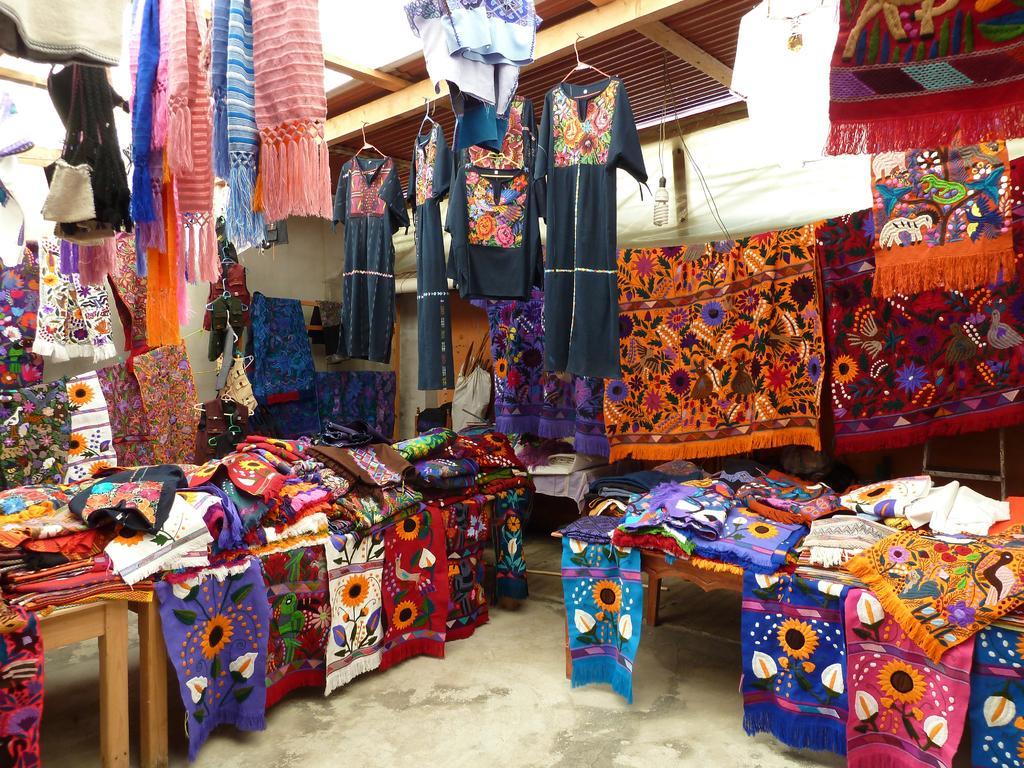How would you summarize this image in a sentence or two? In the image I can see clothes and tables. 